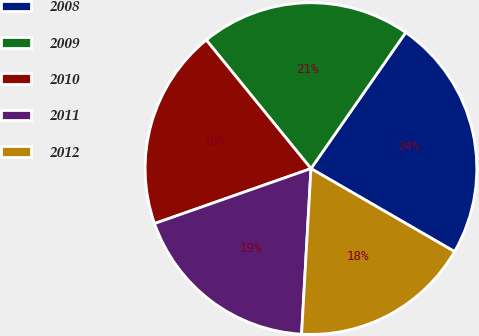Convert chart. <chart><loc_0><loc_0><loc_500><loc_500><pie_chart><fcel>2008<fcel>2009<fcel>2010<fcel>2011<fcel>2012<nl><fcel>23.67%<fcel>20.56%<fcel>19.5%<fcel>18.72%<fcel>17.56%<nl></chart> 